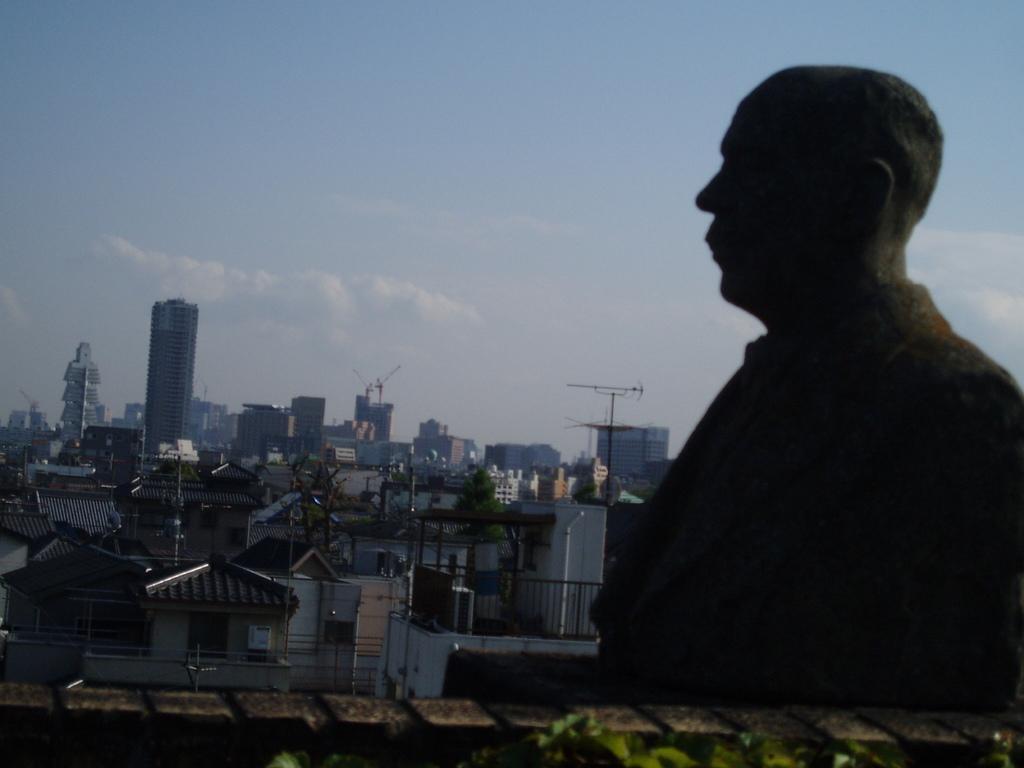Describe this image in one or two sentences. In this image I can see few buildings, windows, railing, poles, sky and in front I can see the statue. 